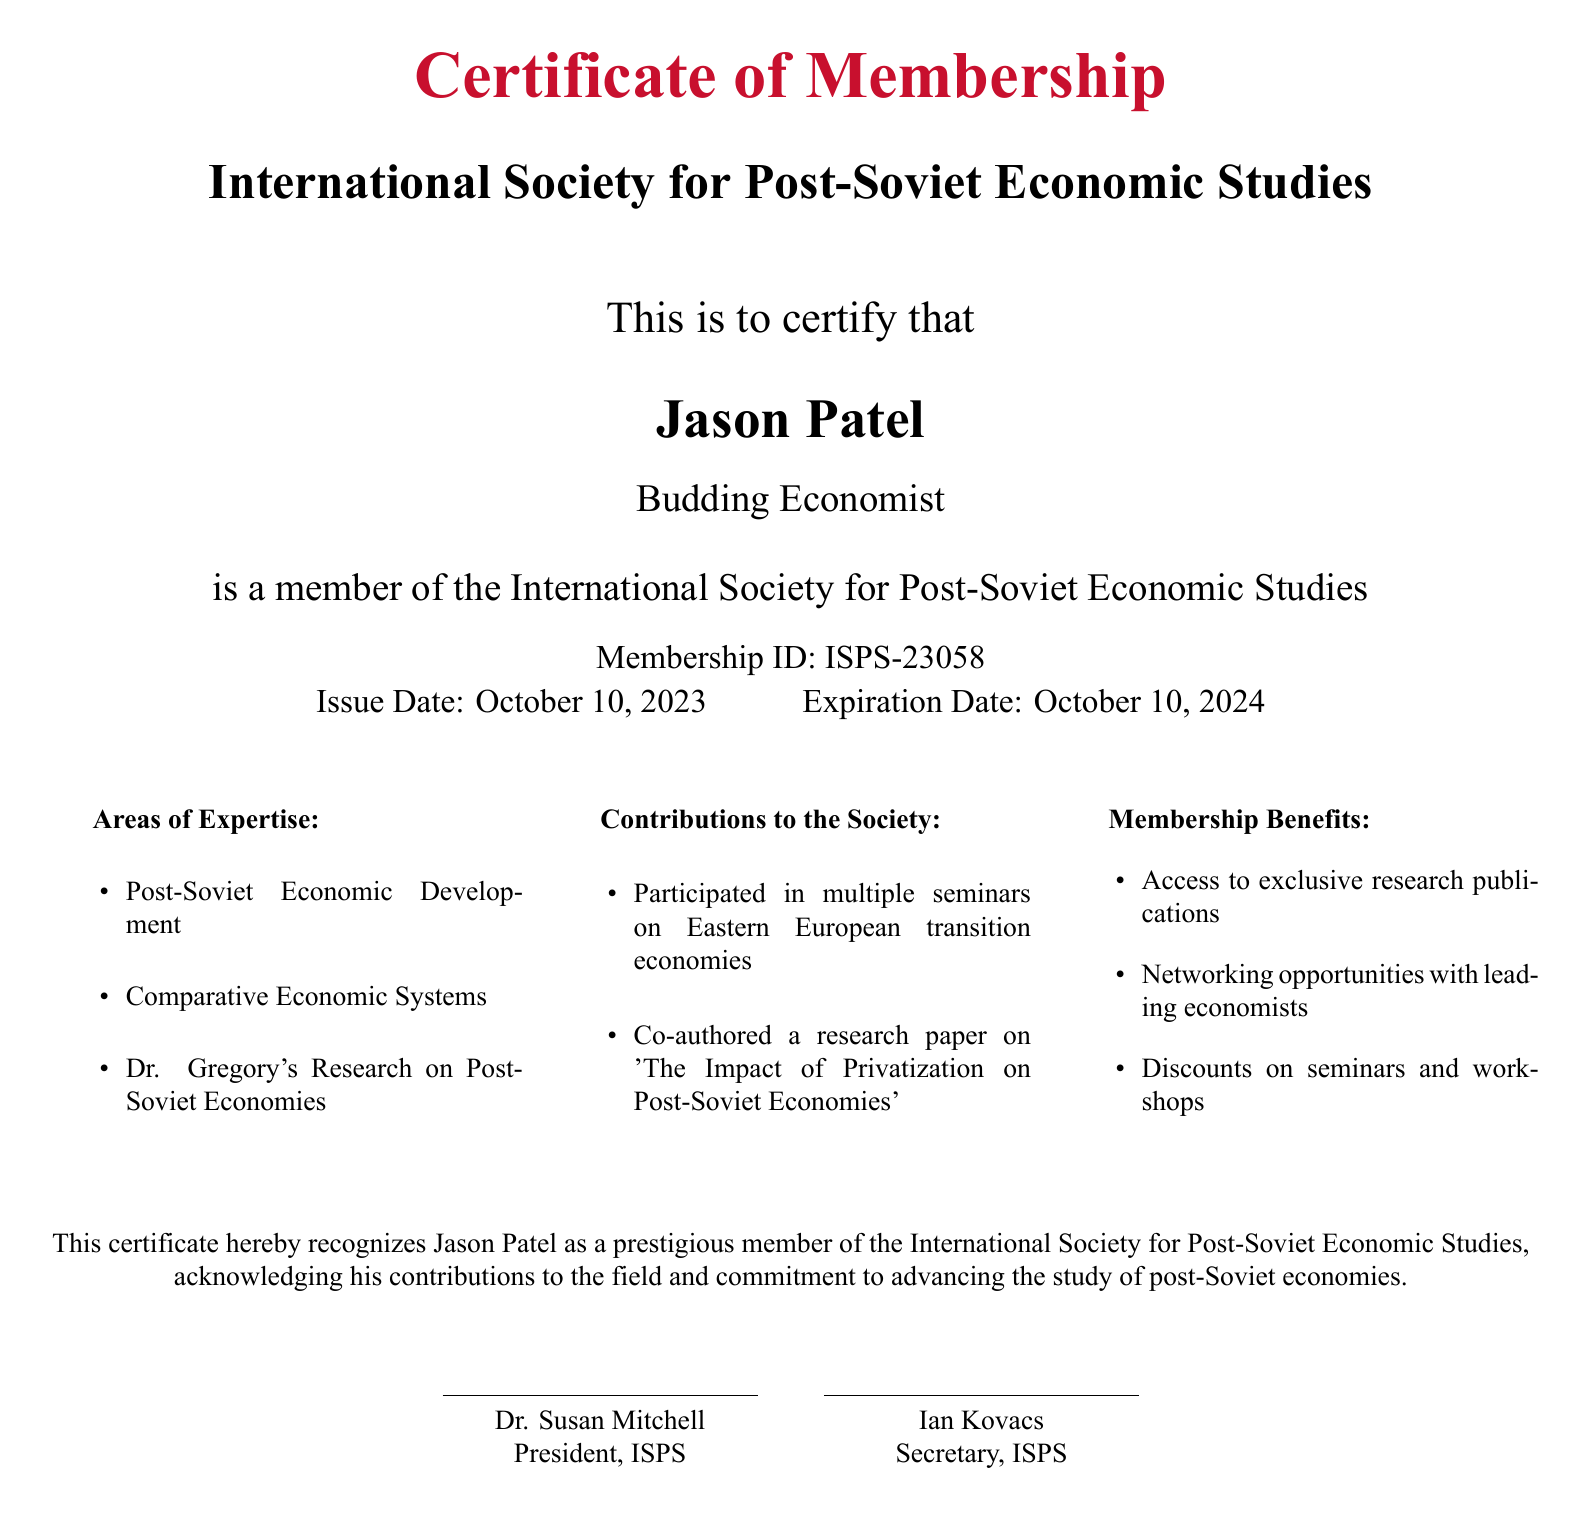What is the title of the certificate? The title of the certificate is prominently displayed at the top of the document as "Certificate of Membership."
Answer: Certificate of Membership Who issued the certificate? The issuing organization is the "International Society for Post-Soviet Economic Studies," which is mentioned directly below the title.
Answer: International Society for Post-Soviet Economic Studies What is Jason Patel's membership ID? The membership ID is specified in the document as part of the membership information.
Answer: ISPS-23058 When was the certificate issued? The issue date is listed in the certificate, showing when it became valid.
Answer: October 10, 2023 What is the expiration date of the membership? This information is clearly stated in the document, indicating how long the membership is valid.
Answer: October 10, 2024 What areas of expertise are listed in the document? The document details specific areas of expertise under a dedicated section.
Answer: Post-Soviet Economic Development, Comparative Economic Systems, Dr. Gregory's Research on Post-Soviet Economies What contributions has Jason Patel made to the Society? The contributions made are summarized in a section within the document, outlining his involvement.
Answer: Participated in multiple seminars on Eastern European transition economies, Co-authored a research paper on 'The Impact of Privatization on Post-Soviet Economies' What are the membership benefits mentioned? The membership benefits are organized in a list format that outlines specific advantages of being a member.
Answer: Access to exclusive research publications, Networking opportunities with leading economists, Discounts on seminars and workshops Who signed the certificate? The document identifies signatories at the bottom, confirming the authenticity of the certificate.
Answer: Dr. Susan Mitchell, Ian Kovacs 